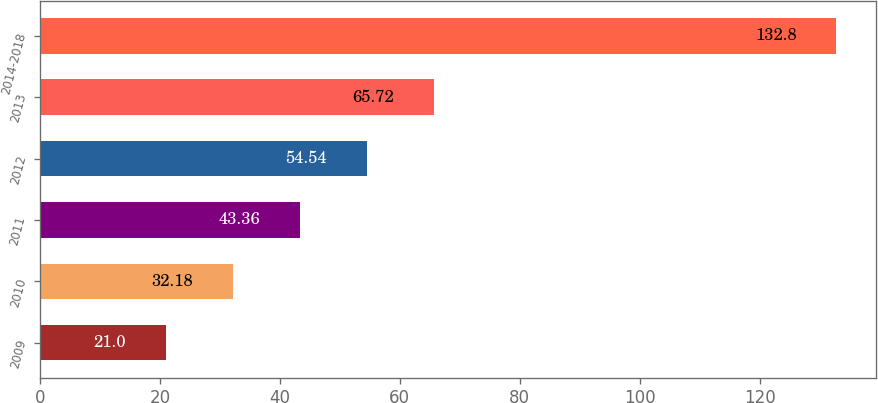Convert chart. <chart><loc_0><loc_0><loc_500><loc_500><bar_chart><fcel>2009<fcel>2010<fcel>2011<fcel>2012<fcel>2013<fcel>2014-2018<nl><fcel>21<fcel>32.18<fcel>43.36<fcel>54.54<fcel>65.72<fcel>132.8<nl></chart> 